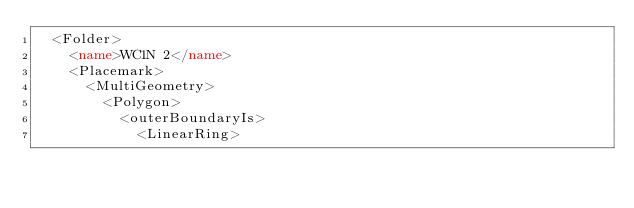<code> <loc_0><loc_0><loc_500><loc_500><_XML_>  <Folder>
    <name>WC1N 2</name>
    <Placemark>
      <MultiGeometry>
        <Polygon>
          <outerBoundaryIs>
            <LinearRing></code> 